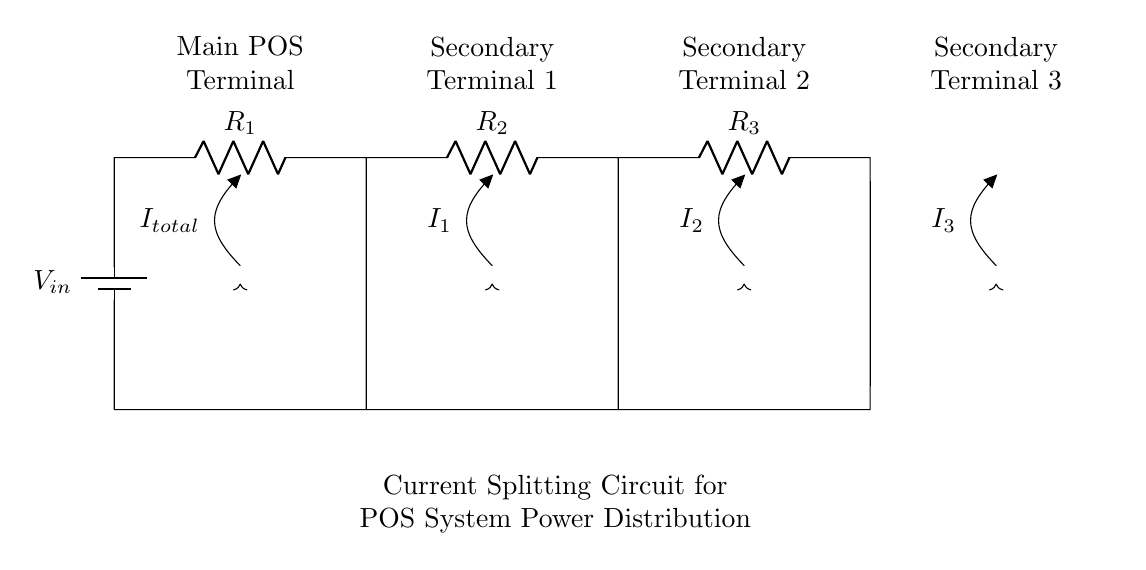What is the input voltage of the circuit? The input voltage is indicated at the battery labeled V_in, which supplies the circuit with electrical energy.
Answer: V_in What resistances are present in the circuit? The circuit contains three resistors labeled R_1, R_2, and R_3 connected in parallel, which are depicted as components in the diagram.
Answer: R_1, R_2, R_3 What does the total current represent in the circuit? The total current, labeled I_total, represents the combined current coming from the input voltage that is divided among the various output paths to the terminals.
Answer: I_total How many secondary terminals are there in the circuit? The diagram shows three secondary terminals, each connected to a different resistor that is part of the current divider setup.
Answer: Three What type of circuit configuration is used here? The circuit employs a parallel configuration, as evidenced by the arrangement of resistors and the division of current among several paths.
Answer: Parallel What is the purpose of the current splitting circuit? The purpose is to distribute electrical power from the main point-of-sale terminal to multiple secondary terminals, ensuring each terminal receives appropriate current.
Answer: Power distribution Which terminal gets the main supply of current? The main supply of current is directed to the main POS terminal, which is indicated as being the entry point for the total current from the input voltage.
Answer: Main POS Terminal 